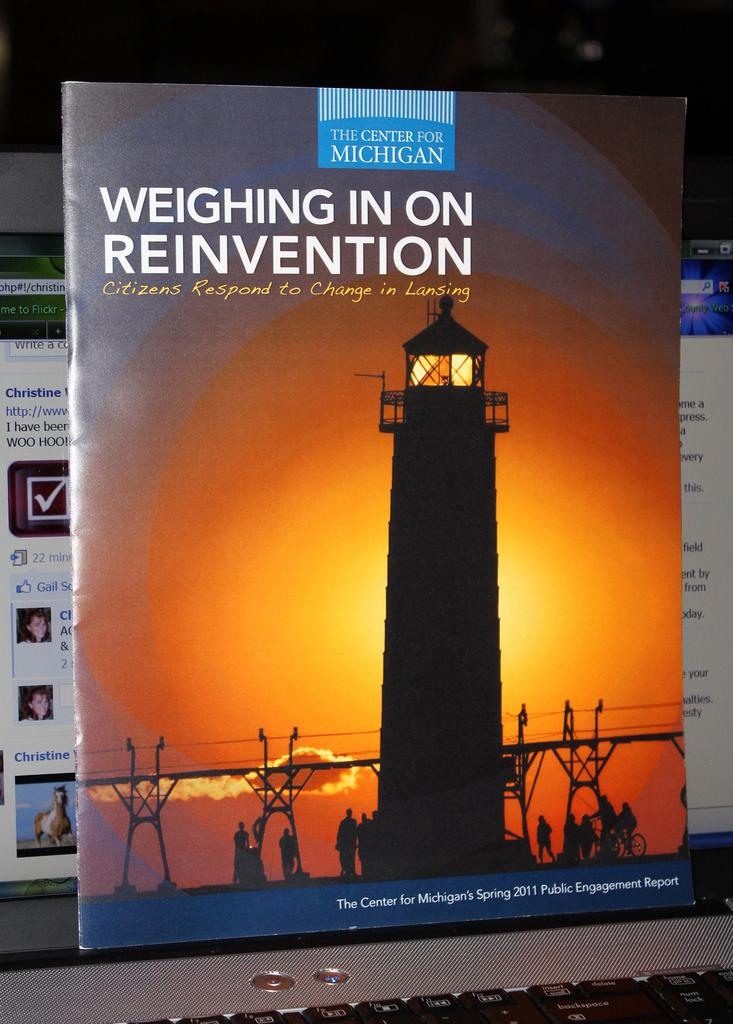<image>
Relay a brief, clear account of the picture shown. The Center for Michigan's Spring 2011 Public Engagement Report is displayed with a picture of a lighthouse on the cover and the words Weighing in On Reinvention. 